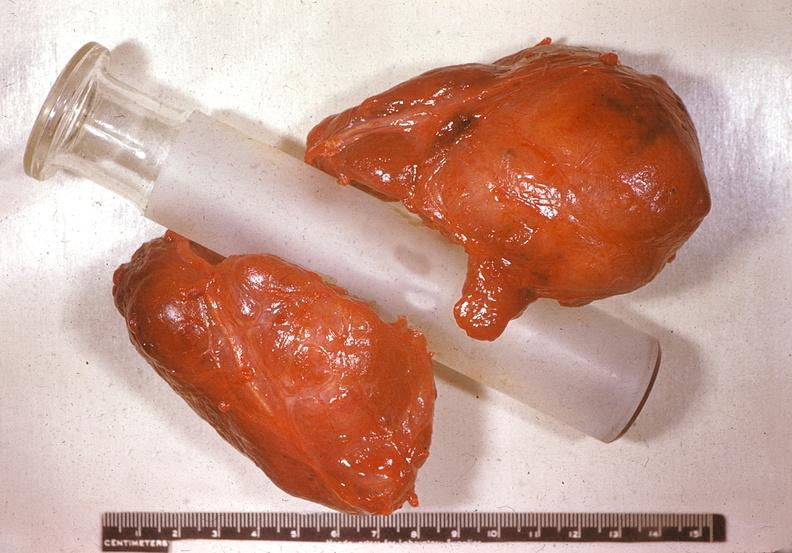does peritoneum show thyroid, nodular colloid goiter?
Answer the question using a single word or phrase. No 